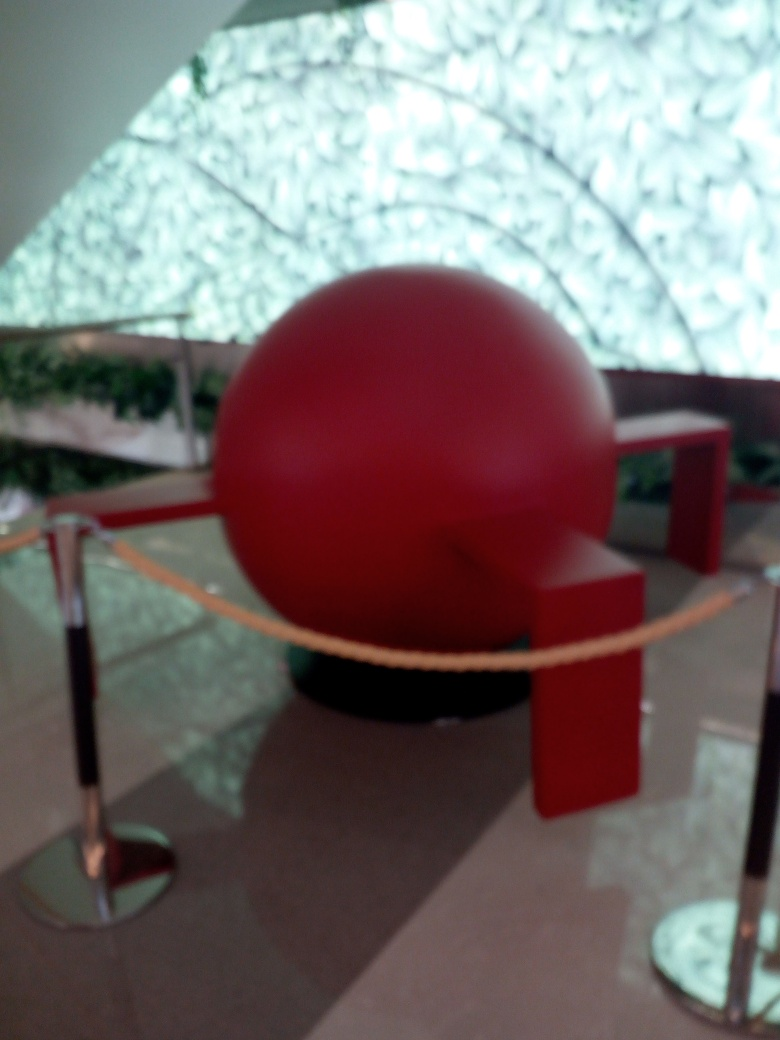What is the atmosphere of the place based on the image? Despite the blurriness of the photo, there's an impression of a calm and quiet atmosphere, possibly a place for contemplation or viewing art. The color scheme is muted except for the bold red centerpiece, which adds a touch of vibrancy to the setting. 